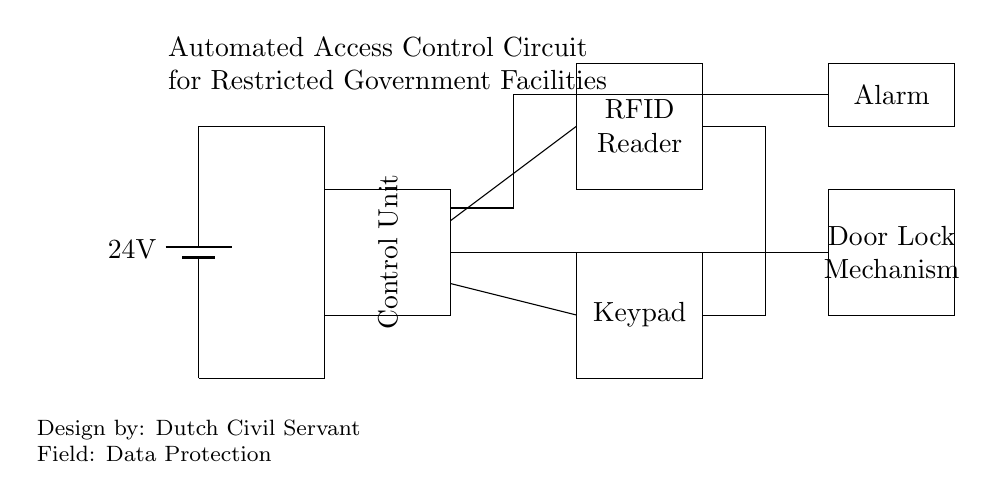What is the voltage provided by the battery? The circuit specifies a battery labeled with 24V, which indicates the voltage provided to the rest of the circuit.
Answer: 24V What is the function of the control unit? The control unit is labeled within the circuit diagram and serves to manage the access control process, interfacing with both the RFID reader and keypad.
Answer: Access management Which component interacts with the keypad? The diagram shows a connection from the keypad to the control unit, indicating that the keypad is used to input access codes which the control unit will process.
Answer: Control unit What component triggers the alarm? The alarm is connected to the control unit via a connection indicating that when the control unit detects an unauthorized access, it signals the alarm to activate.
Answer: Control unit How many main components are in the circuit? By counting the distinct components shown in the diagram, there are five main components: the battery, control unit, RFID reader, keypad, and door lock mechanism.
Answer: Five What type of access method is used in this circuit? The presence of an RFID reader in the circuit indicates that this system utilizes radio-frequency identification as a method for access control, reading credentials from RFID tags.
Answer: RFID What happens when unauthorized access is detected? When the control unit processes an unauthorized request from either the keypad or RFID reader, it triggers the alarm as per the connections laid out in the circuit.
Answer: Alarm activation 